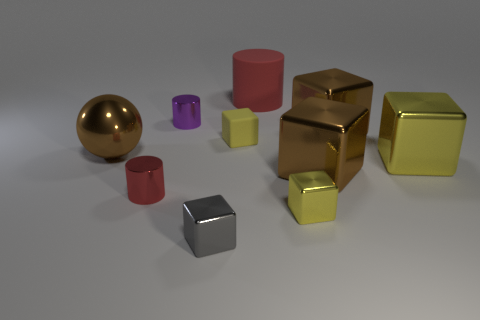Subtract all gray metal blocks. How many blocks are left? 5 Subtract all red cylinders. How many cylinders are left? 1 Subtract all cyan cylinders. How many brown blocks are left? 2 Add 10 big red metal cubes. How many big red metal cubes exist? 10 Subtract 0 blue balls. How many objects are left? 10 Subtract all blocks. How many objects are left? 4 Subtract 1 cylinders. How many cylinders are left? 2 Subtract all green spheres. Subtract all gray cylinders. How many spheres are left? 1 Subtract all brown metal blocks. Subtract all large yellow blocks. How many objects are left? 7 Add 8 tiny red objects. How many tiny red objects are left? 9 